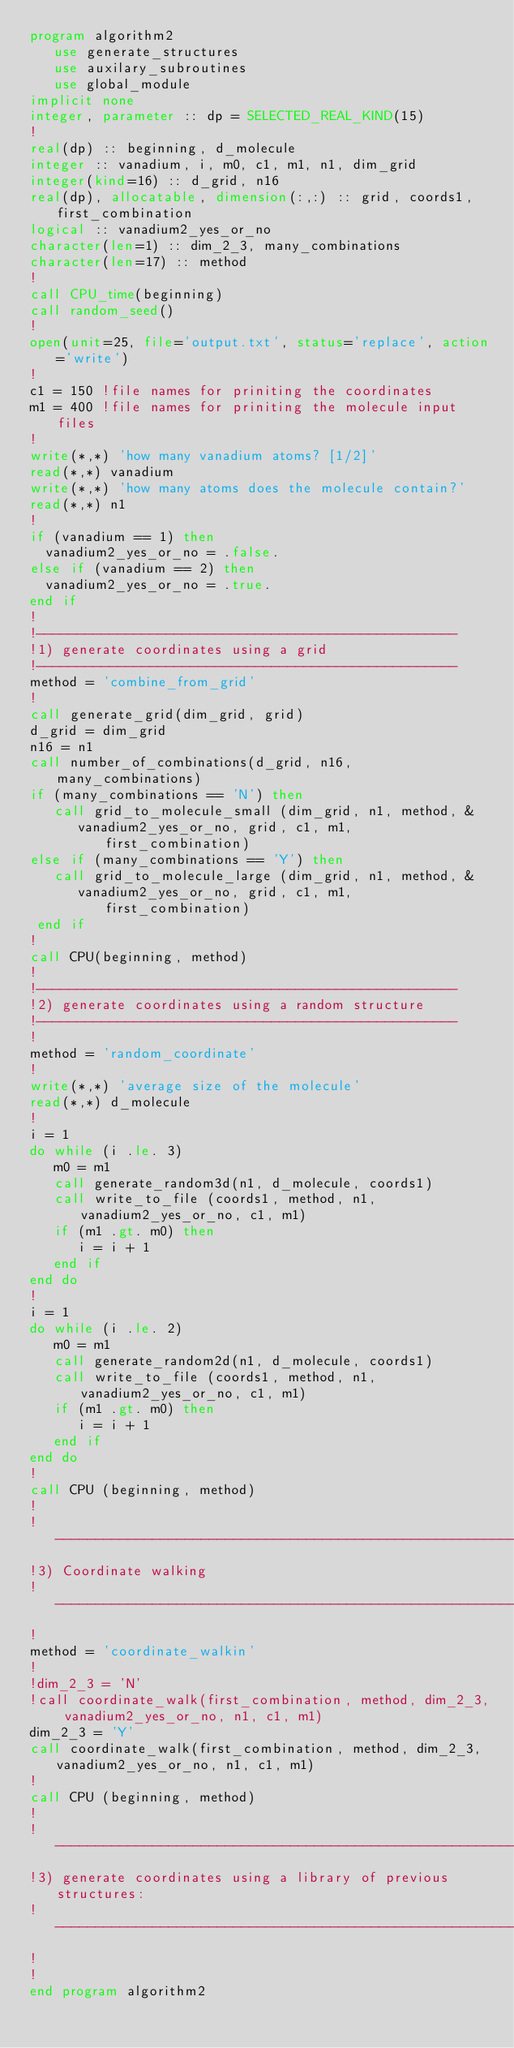Convert code to text. <code><loc_0><loc_0><loc_500><loc_500><_FORTRAN_>program algorithm2
   use generate_structures
   use auxilary_subroutines
   use global_module
implicit none
integer, parameter :: dp = SELECTED_REAL_KIND(15)
!
real(dp) :: beginning, d_molecule
integer :: vanadium, i, m0, c1, m1, n1, dim_grid
integer(kind=16) :: d_grid, n16
real(dp), allocatable, dimension(:,:) :: grid, coords1, first_combination
logical :: vanadium2_yes_or_no 
character(len=1) :: dim_2_3, many_combinations
character(len=17) :: method
!
call CPU_time(beginning)
call random_seed()
!
open(unit=25, file='output.txt', status='replace', action='write')
!
c1 = 150 !file names for priniting the coordinates
m1 = 400 !file names for priniting the molecule input files
!
write(*,*) 'how many vanadium atoms? [1/2]'
read(*,*) vanadium
write(*,*) 'how many atoms does the molecule contain?'
read(*,*) n1
!
if (vanadium == 1) then
  vanadium2_yes_or_no = .false.
else if (vanadium == 2) then
  vanadium2_yes_or_no = .true.
end if
!
!----------------------------------------------------
!1) generate coordinates using a grid
!----------------------------------------------------
method = 'combine_from_grid'
!
call generate_grid(dim_grid, grid)
d_grid = dim_grid
n16 = n1
call number_of_combinations(d_grid, n16, many_combinations)
if (many_combinations == 'N') then
   call grid_to_molecule_small (dim_grid, n1, method, &
      vanadium2_yes_or_no, grid, c1, m1, first_combination)
else if (many_combinations == 'Y') then
   call grid_to_molecule_large (dim_grid, n1, method, &
      vanadium2_yes_or_no, grid, c1, m1, first_combination)
 end if
!
call CPU(beginning, method)
!
!----------------------------------------------------
!2) generate coordinates using a random structure
!----------------------------------------------------
!
method = 'random_coordinate'
!
write(*,*) 'average size of the molecule'
read(*,*) d_molecule
!
i = 1
do while (i .le. 3)
   m0 = m1
   call generate_random3d(n1, d_molecule, coords1)
   call write_to_file (coords1, method, n1, vanadium2_yes_or_no, c1, m1)
   if (m1 .gt. m0) then
      i = i + 1
   end if
end do
!
i = 1
do while (i .le. 2)
   m0 = m1
   call generate_random2d(n1, d_molecule, coords1)
   call write_to_file (coords1, method, n1, vanadium2_yes_or_no, c1, m1)
   if (m1 .gt. m0) then
      i = i + 1
   end if
end do
!
call CPU (beginning, method)
!
!------------------------------------------------------------------
!3) Coordinate walking
!-----------------------------------------------------------------
!
method = 'coordinate_walkin'
!
!dim_2_3 = 'N'
!call coordinate_walk(first_combination, method, dim_2_3, vanadium2_yes_or_no, n1, c1, m1)
dim_2_3 = 'Y'
call coordinate_walk(first_combination, method, dim_2_3, vanadium2_yes_or_no, n1, c1, m1)
!
call CPU (beginning, method)
!
!---------------------------------------------------------------
!3) generate coordinates using a library of previous structures:
!---------------------------------------------------------------
!
!
end program algorithm2
</code> 